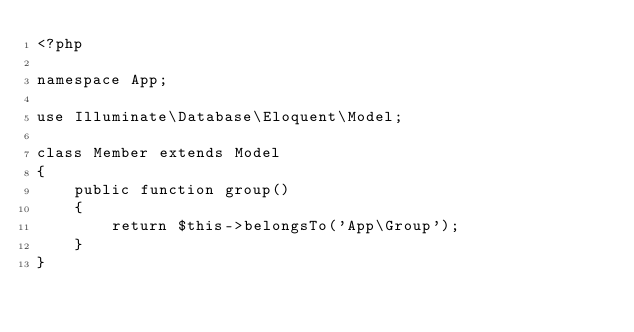<code> <loc_0><loc_0><loc_500><loc_500><_PHP_><?php

namespace App;

use Illuminate\Database\Eloquent\Model;

class Member extends Model
{
    public function group()
    {
    	return $this->belongsTo('App\Group');
    }
}
</code> 